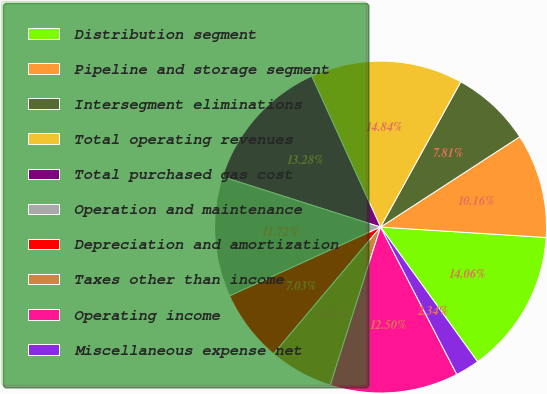<chart> <loc_0><loc_0><loc_500><loc_500><pie_chart><fcel>Distribution segment<fcel>Pipeline and storage segment<fcel>Intersegment eliminations<fcel>Total operating revenues<fcel>Total purchased gas cost<fcel>Operation and maintenance<fcel>Depreciation and amortization<fcel>Taxes other than income<fcel>Operating income<fcel>Miscellaneous expense net<nl><fcel>14.06%<fcel>10.16%<fcel>7.81%<fcel>14.84%<fcel>13.28%<fcel>11.72%<fcel>7.03%<fcel>6.25%<fcel>12.5%<fcel>2.34%<nl></chart> 